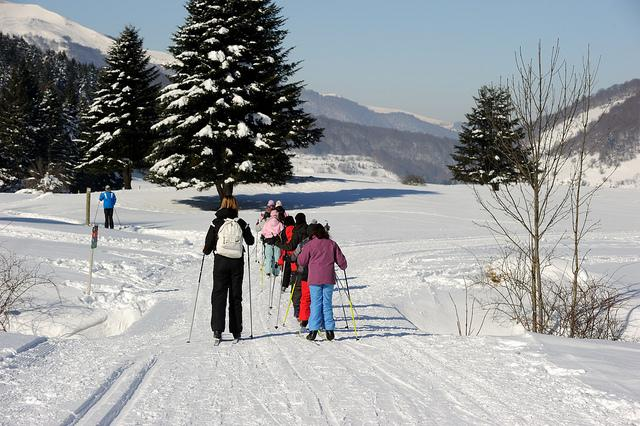What kind of terrain is best for this activity?

Choices:
A) downhill
B) rocky
C) flat
D) uphill flat 